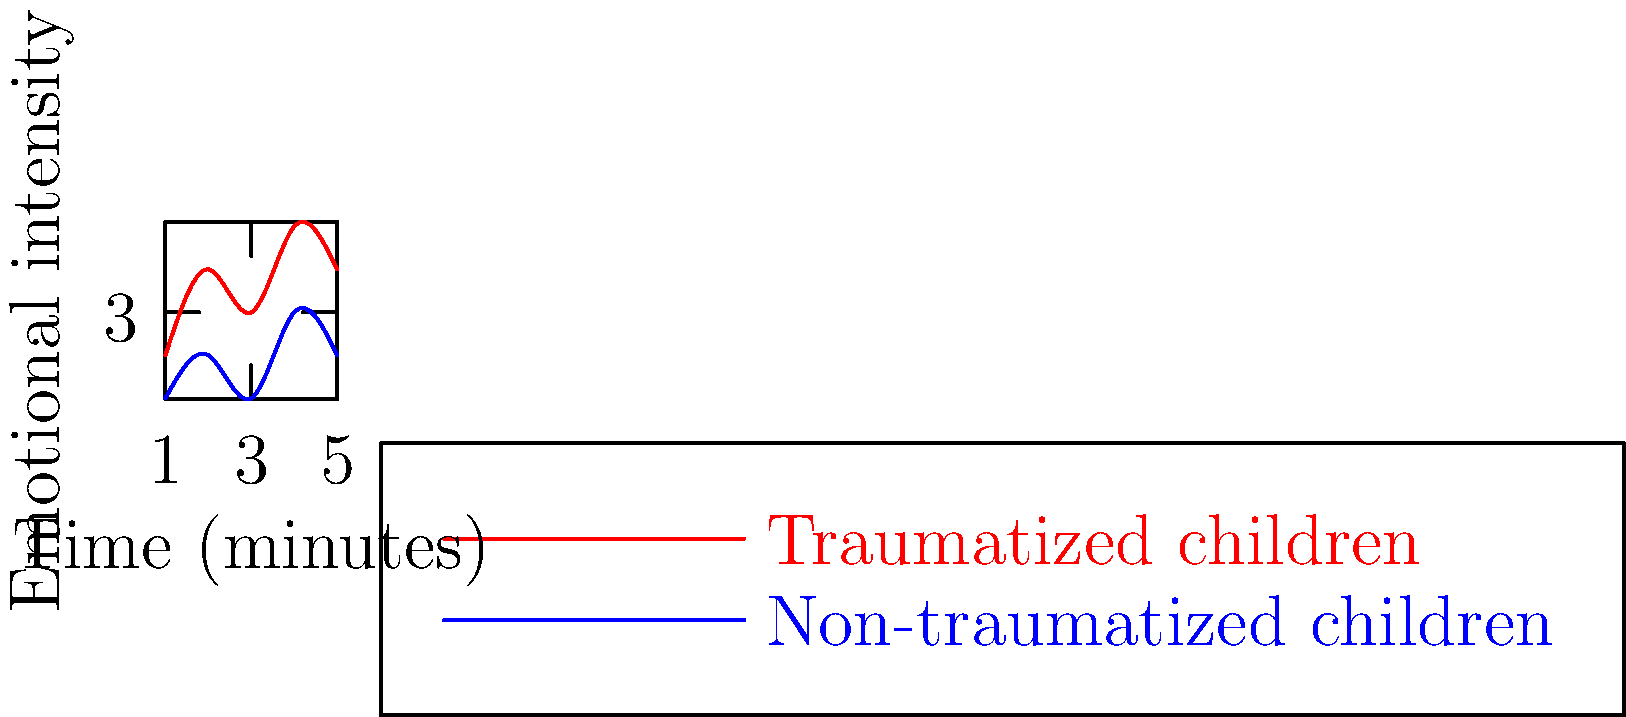Based on the facial expression recognition chart above, which shows emotional intensity over time for traumatized and non-traumatized children during a stress-inducing task, what can be inferred about the emotional regulation differences between the two groups? To interpret the emotional regulation differences between traumatized and non-traumatized children using the facial expression recognition chart, we need to analyze the following aspects:

1. Initial emotional intensity:
   - Traumatized children start at a higher emotional intensity (y = 2) compared to non-traumatized children (y = 1).

2. Range of emotional intensity:
   - Traumatized children show a wider range of emotional intensity (from 2 to 5) compared to non-traumatized children (from 1 to 3).

3. Fluctuations in emotional intensity:
   - Traumatized children exhibit more frequent and larger fluctuations in emotional intensity over time.
   - Non-traumatized children show more stable and gradual changes in emotional intensity.

4. Peak emotional intensity:
   - Traumatized children reach a higher peak emotional intensity (y = 5) compared to non-traumatized children (y = 3).

5. Overall trend:
   - Both groups show an increasing trend in emotional intensity over time, but the increase is more pronounced and variable for traumatized children.

These observations suggest that traumatized children have greater difficulty regulating their emotions during stress-inducing tasks. They experience more intense emotional reactions, greater variability in emotional states, and less ability to maintain emotional stability compared to non-traumatized children.
Answer: Traumatized children show greater emotional dysregulation, characterized by higher initial and peak intensities, wider range, and more frequent fluctuations in emotional states compared to non-traumatized children. 